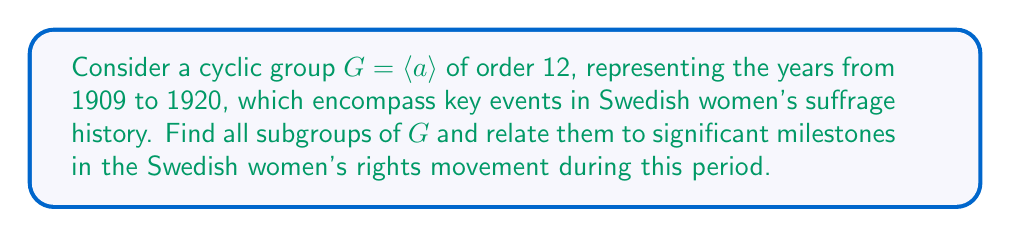Could you help me with this problem? To solve this problem, we'll follow these steps:

1) First, recall that in a cyclic group of order $n$, the subgroups correspond to the divisors of $n$. The order 12 has divisors 1, 2, 3, 4, 6, and 12.

2) For each divisor $d$ of 12, there is a unique subgroup of order $d$, generated by $a^{12/d}$. Let's list these subgroups:

   $H_1 = \langle a^{12} \rangle = \{e\}$ (order 1)
   $H_2 = \langle a^6 \rangle = \{e, a^6\}$ (order 2)
   $H_3 = \langle a^4 \rangle = \{e, a^4, a^8\}$ (order 3)
   $H_4 = \langle a^3 \rangle = \{e, a^3, a^6, a^9\}$ (order 4)
   $H_6 = \langle a^2 \rangle = \{e, a^2, a^4, a^6, a^8, a^{10}\}$ (order 6)
   $H_{12} = \langle a \rangle = G$ (order 12)

3) Now, let's relate these subgroups to events in Swedish women's suffrage history:

   $H_1$ (1909): Formation of the National Association for Women's Suffrage (LKPR)
   $H_2$ (1909, 1915): 1909 - Municipal suffrage for women; 1915 - Proposal for universal suffrage
   $H_3$ (1909, 1913, 1917): 1909 - Municipal suffrage; 1913 - National petition for women's suffrage; 1917 - Women's Suffrage Day demonstration
   $H_4$ (1909, 1912, 1915, 1918): Adding 1912 - Constitutional committee considers women's suffrage; 1918 - Parliament approves universal suffrage
   $H_6$ (1909, 1911, 1913, 1915, 1917, 1919): Adding 1911 - First woman elected to city council; 1919 - Women's suffrage bill passes
   $H_{12}$ (1909-1920): Entire period of suffrage movement, culminating in 1921 when women voted in national elections for the first time

This representation allows us to see how the subgroups of $G$ correspond to key years and events in the Swedish women's suffrage movement, with larger subgroups encompassing more milestones.
Answer: The subgroups of $G$ are:
$H_1 = \{e\}$, $H_2 = \langle a^6 \rangle$, $H_3 = \langle a^4 \rangle$, $H_4 = \langle a^3 \rangle$, $H_6 = \langle a^2 \rangle$, and $H_{12} = G = \langle a \rangle$, each corresponding to significant events in the Swedish women's suffrage movement from 1909 to 1920. 